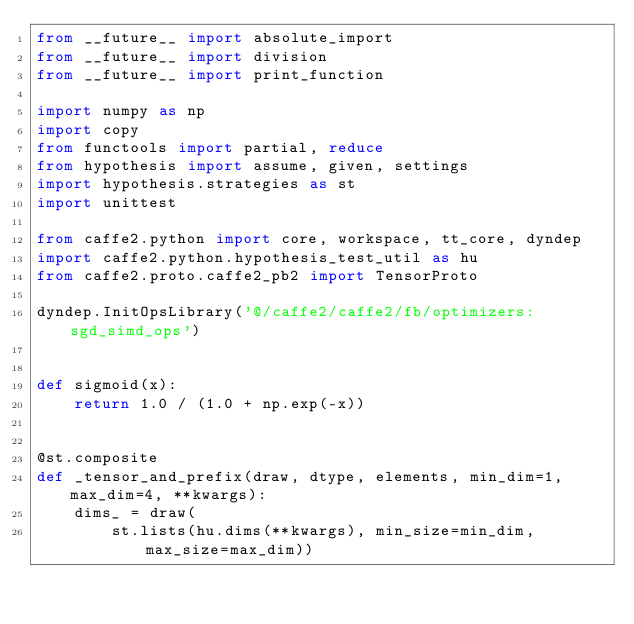<code> <loc_0><loc_0><loc_500><loc_500><_Python_>from __future__ import absolute_import
from __future__ import division
from __future__ import print_function

import numpy as np
import copy
from functools import partial, reduce
from hypothesis import assume, given, settings
import hypothesis.strategies as st
import unittest

from caffe2.python import core, workspace, tt_core, dyndep
import caffe2.python.hypothesis_test_util as hu
from caffe2.proto.caffe2_pb2 import TensorProto

dyndep.InitOpsLibrary('@/caffe2/caffe2/fb/optimizers:sgd_simd_ops')


def sigmoid(x):
    return 1.0 / (1.0 + np.exp(-x))


@st.composite
def _tensor_and_prefix(draw, dtype, elements, min_dim=1, max_dim=4, **kwargs):
    dims_ = draw(
        st.lists(hu.dims(**kwargs), min_size=min_dim, max_size=max_dim))</code> 